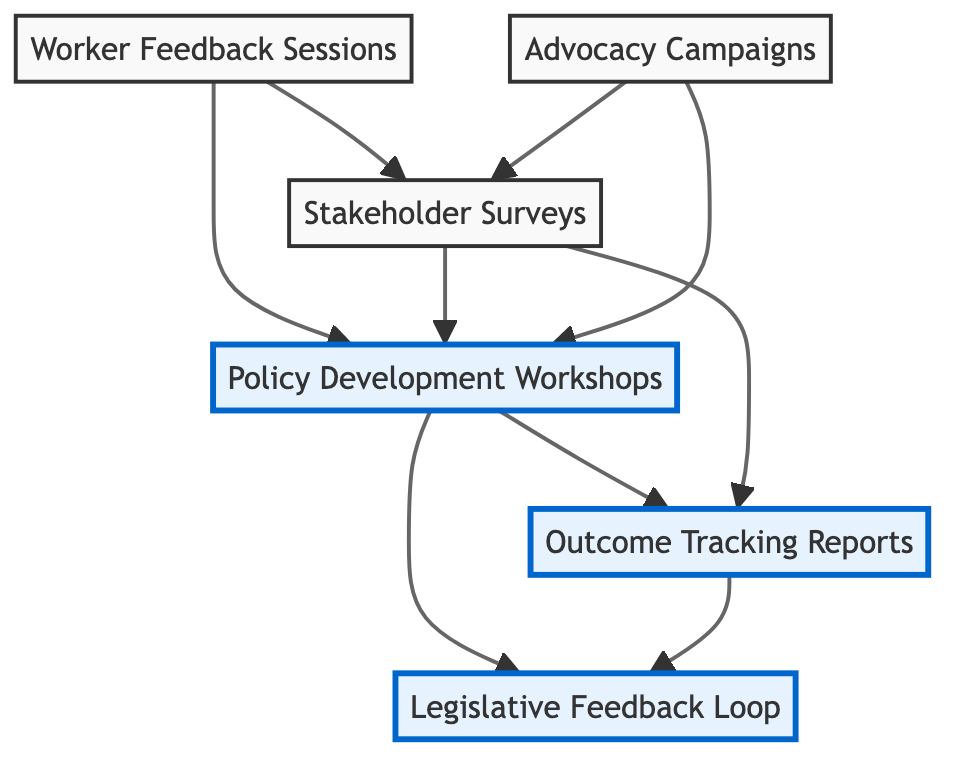What is the first node in the flowchart? The first node in the flowchart is "Worker Feedback Sessions," as indicated at the top of the diagram.
Answer: Worker Feedback Sessions How many nodes are in the diagram? There are six distinct nodes present in the diagram, each representing a different component of the workers' rights advocacy initiatives.
Answer: Six What do "Advocacy Campaigns" and "Stakeholder Surveys" have in common? Both "Advocacy Campaigns" and "Stakeholder Surveys" flow into "Policy Development Workshops," indicating they both contribute insights for policy creation.
Answer: They both flow into Policy Development Workshops Which node directly leads to "Outcome Tracking Reports"? The "Policy Development Workshops" and "Stakeholder Surveys" both directly lead to "Outcome Tracking Reports," showing that both contribute to documenting the effects of changes.
Answer: Policy Development Workshops and Stakeholder Surveys What is the relationship between "Outcome Tracking Reports" and "Legislative Feedback Loop"? "Outcome Tracking Reports" leads to "Legislative Feedback Loop," suggesting that the outcomes influence further reviews of legislation.
Answer: Outcome Tracking Reports leads to Legislative Feedback Loop How many nodes lead into "Policy Development Workshops"? There are three nodes that lead into "Policy Development Workshops": "Worker Feedback Sessions," "Stakeholder Surveys," and "Advocacy Campaigns."
Answer: Three What type of feedback is captured in "Legislative Feedback Loop"? "Legislative Feedback Loop" captures continuous review and input from stakeholders about new laws, indicating ongoing engagement after legislation is enacted.
Answer: Continuous review and input Which node initiates the process of gathering insights? The "Worker Feedback Sessions" node initiates the process by gathering insights from workers regarding their rights and challenges.
Answer: Worker Feedback Sessions 